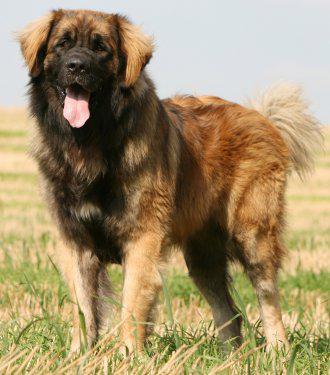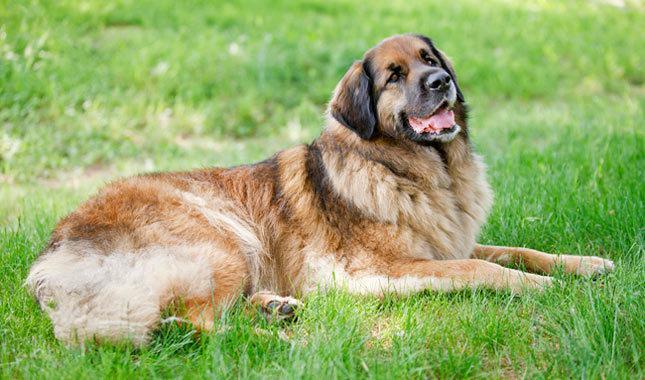The first image is the image on the left, the second image is the image on the right. For the images shown, is this caption "The dog in the image on the right is standing outside alone." true? Answer yes or no. No. The first image is the image on the left, the second image is the image on the right. For the images shown, is this caption "In one image you can only see the dogs head." true? Answer yes or no. No. The first image is the image on the left, the second image is the image on the right. Evaluate the accuracy of this statement regarding the images: "One photo is a closeup of a dog's head and shoulders.". Is it true? Answer yes or no. No. The first image is the image on the left, the second image is the image on the right. For the images displayed, is the sentence "A dog with its face turned rightward is standing still on the grass in one image." factually correct? Answer yes or no. No. 